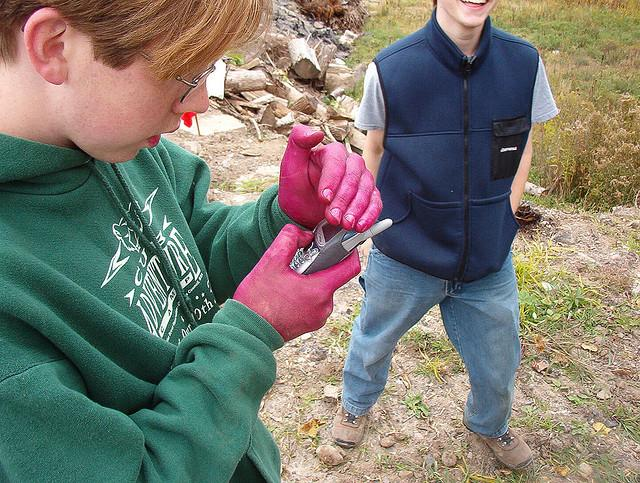Why is the boy blocking the view of his phone? privacy 